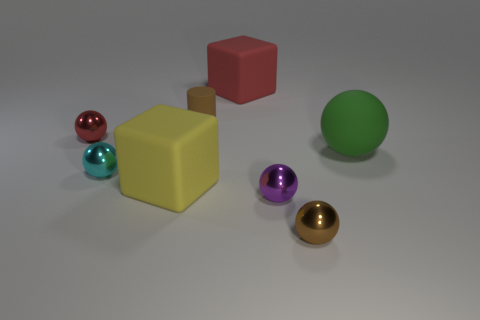Add 1 large yellow spheres. How many objects exist? 9 Subtract all brown metal spheres. How many spheres are left? 4 Subtract 1 spheres. How many spheres are left? 4 Subtract all red balls. How many balls are left? 4 Subtract all balls. How many objects are left? 3 Add 2 green spheres. How many green spheres exist? 3 Subtract 1 red balls. How many objects are left? 7 Subtract all red blocks. Subtract all brown cylinders. How many blocks are left? 1 Subtract all purple blocks. Subtract all yellow matte objects. How many objects are left? 7 Add 1 tiny cyan things. How many tiny cyan things are left? 2 